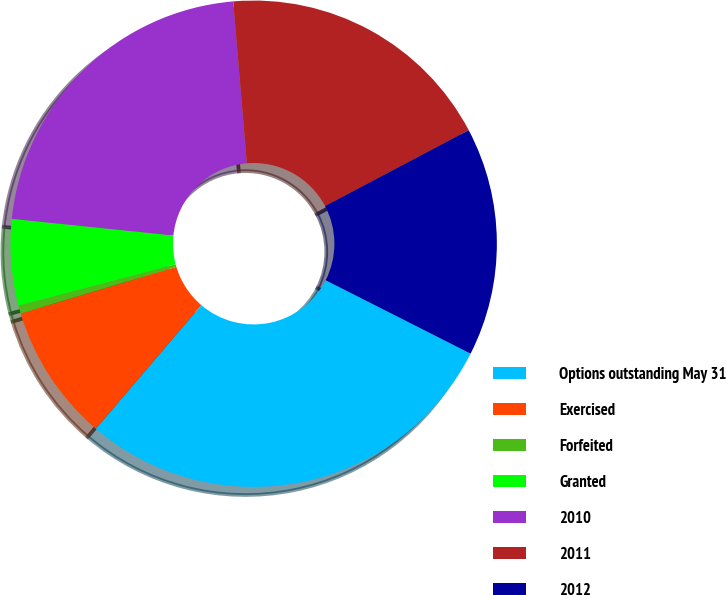<chart> <loc_0><loc_0><loc_500><loc_500><pie_chart><fcel>Options outstanding May 31<fcel>Exercised<fcel>Forfeited<fcel>Granted<fcel>2010<fcel>2011<fcel>2012<nl><fcel>28.78%<fcel>9.13%<fcel>0.54%<fcel>5.72%<fcel>22.02%<fcel>18.61%<fcel>15.19%<nl></chart> 